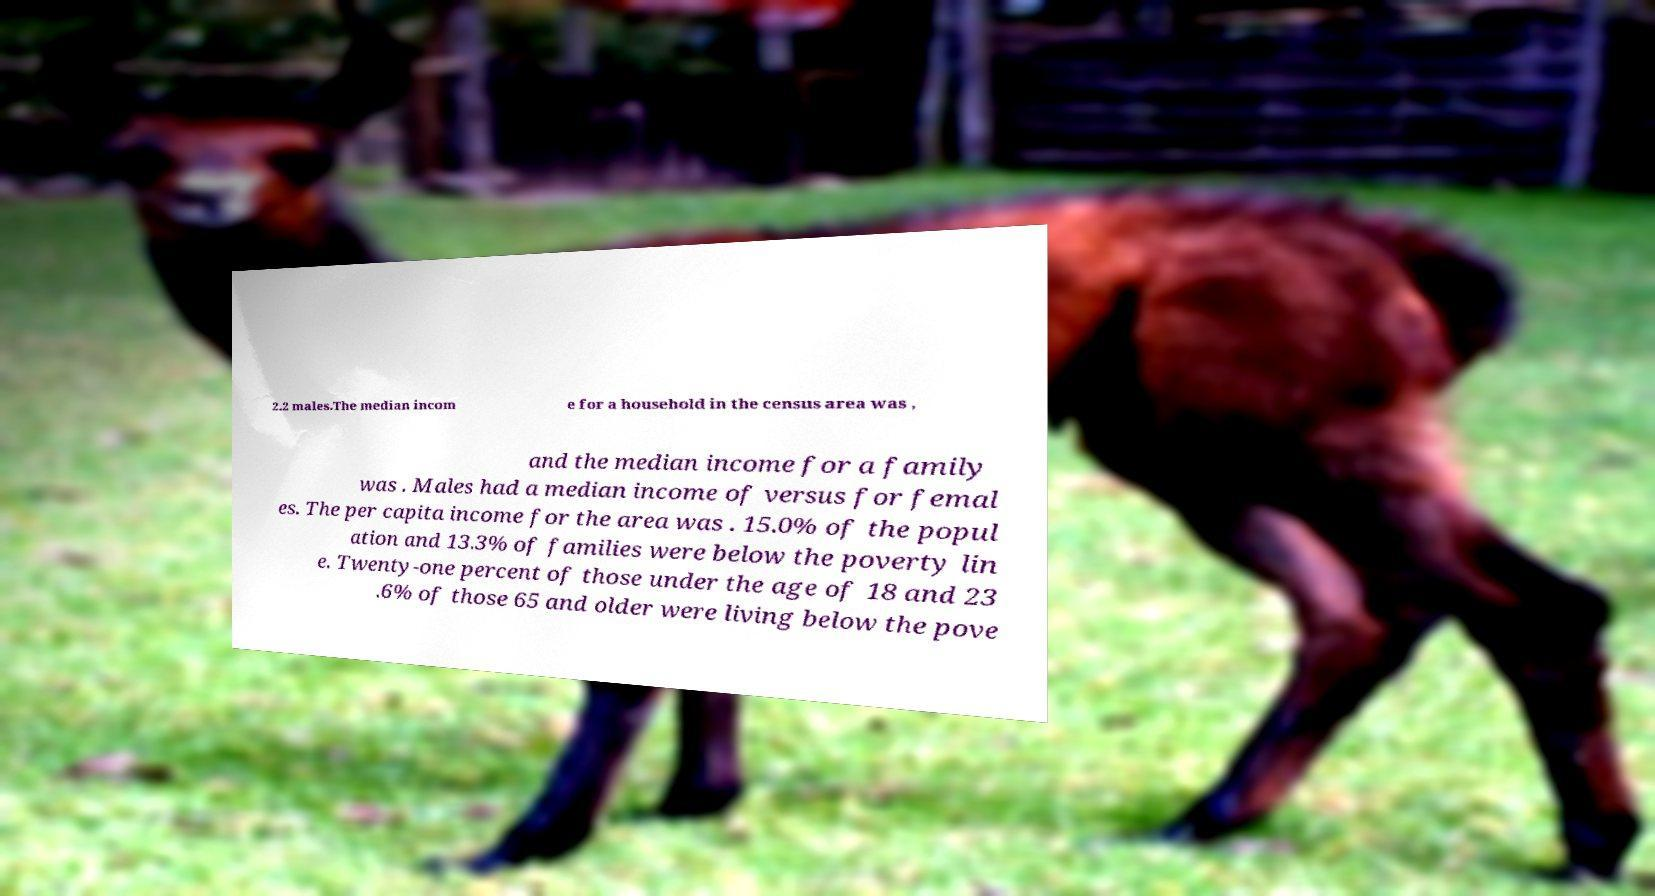What messages or text are displayed in this image? I need them in a readable, typed format. 2.2 males.The median incom e for a household in the census area was , and the median income for a family was . Males had a median income of versus for femal es. The per capita income for the area was . 15.0% of the popul ation and 13.3% of families were below the poverty lin e. Twenty-one percent of those under the age of 18 and 23 .6% of those 65 and older were living below the pove 